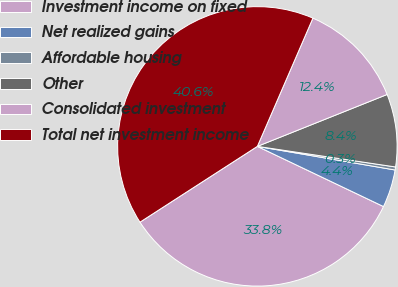<chart> <loc_0><loc_0><loc_500><loc_500><pie_chart><fcel>Investment income on fixed<fcel>Net realized gains<fcel>Affordable housing<fcel>Other<fcel>Consolidated investment<fcel>Total net investment income<nl><fcel>33.79%<fcel>4.38%<fcel>0.35%<fcel>8.41%<fcel>12.44%<fcel>40.63%<nl></chart> 